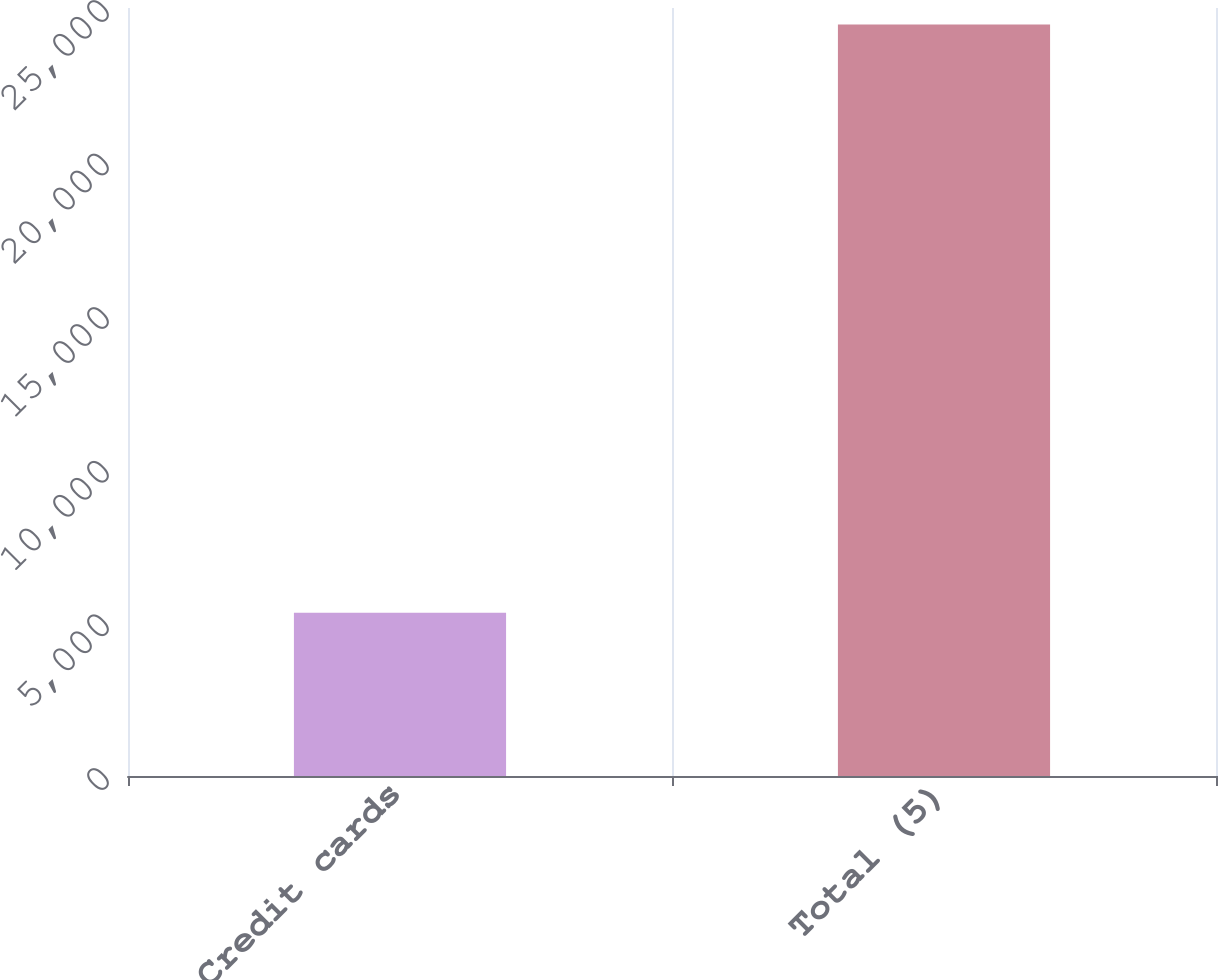<chart> <loc_0><loc_0><loc_500><loc_500><bar_chart><fcel>Credit cards<fcel>Total (5)<nl><fcel>5314<fcel>24466<nl></chart> 